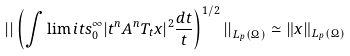<formula> <loc_0><loc_0><loc_500><loc_500>\left | \right | \left ( \int \lim i t s _ { 0 } ^ { \infty } | t ^ { n } A ^ { n } T _ { t } x | ^ { 2 } \frac { d t } { t } \right ) ^ { 1 / 2 } \left | \right | _ { L _ { p } ( \Omega ) } \simeq \| x \| _ { L _ { p } ( \Omega ) }</formula> 